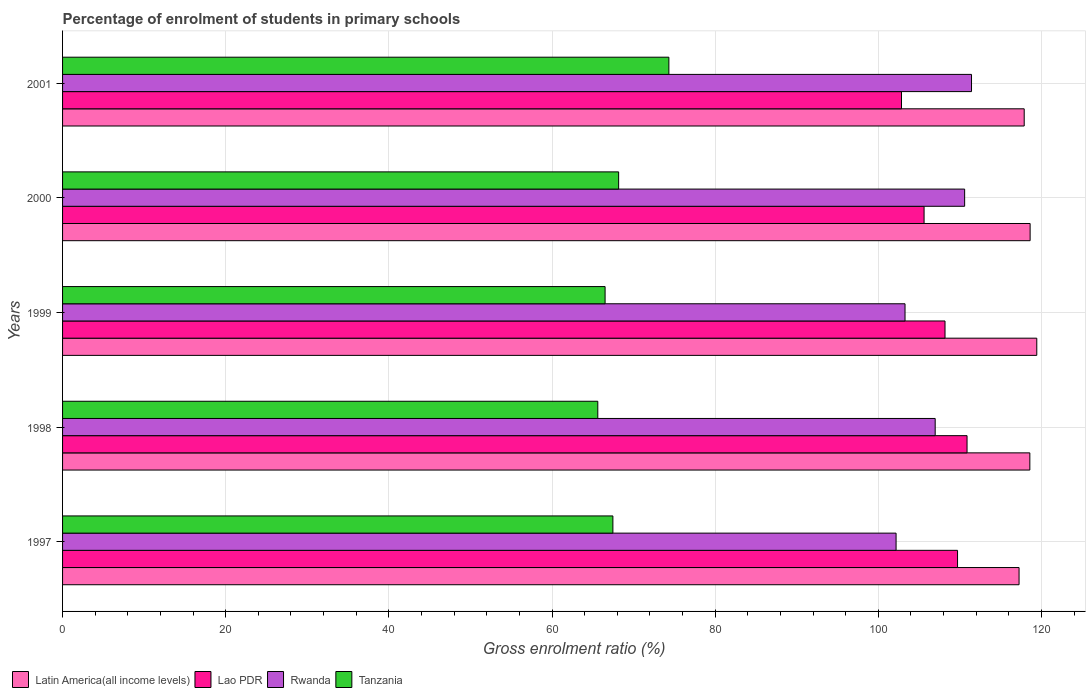Are the number of bars on each tick of the Y-axis equal?
Make the answer very short. Yes. What is the percentage of students enrolled in primary schools in Latin America(all income levels) in 1998?
Provide a short and direct response. 118.58. Across all years, what is the maximum percentage of students enrolled in primary schools in Lao PDR?
Offer a very short reply. 110.88. Across all years, what is the minimum percentage of students enrolled in primary schools in Lao PDR?
Your answer should be compact. 102.84. In which year was the percentage of students enrolled in primary schools in Lao PDR minimum?
Your answer should be very brief. 2001. What is the total percentage of students enrolled in primary schools in Latin America(all income levels) in the graph?
Offer a very short reply. 591.75. What is the difference between the percentage of students enrolled in primary schools in Rwanda in 1999 and that in 2001?
Your answer should be very brief. -8.15. What is the difference between the percentage of students enrolled in primary schools in Rwanda in 2000 and the percentage of students enrolled in primary schools in Tanzania in 1997?
Give a very brief answer. 43.12. What is the average percentage of students enrolled in primary schools in Lao PDR per year?
Ensure brevity in your answer.  107.44. In the year 2000, what is the difference between the percentage of students enrolled in primary schools in Rwanda and percentage of students enrolled in primary schools in Lao PDR?
Your response must be concise. 4.97. In how many years, is the percentage of students enrolled in primary schools in Rwanda greater than 88 %?
Your answer should be compact. 5. What is the ratio of the percentage of students enrolled in primary schools in Tanzania in 1998 to that in 2001?
Provide a succinct answer. 0.88. What is the difference between the highest and the second highest percentage of students enrolled in primary schools in Lao PDR?
Your answer should be very brief. 1.16. What is the difference between the highest and the lowest percentage of students enrolled in primary schools in Lao PDR?
Provide a succinct answer. 8.03. Is it the case that in every year, the sum of the percentage of students enrolled in primary schools in Lao PDR and percentage of students enrolled in primary schools in Tanzania is greater than the sum of percentage of students enrolled in primary schools in Latin America(all income levels) and percentage of students enrolled in primary schools in Rwanda?
Provide a short and direct response. No. What does the 2nd bar from the top in 1998 represents?
Ensure brevity in your answer.  Rwanda. What does the 3rd bar from the bottom in 1997 represents?
Make the answer very short. Rwanda. Is it the case that in every year, the sum of the percentage of students enrolled in primary schools in Latin America(all income levels) and percentage of students enrolled in primary schools in Lao PDR is greater than the percentage of students enrolled in primary schools in Tanzania?
Keep it short and to the point. Yes. Are all the bars in the graph horizontal?
Your response must be concise. Yes. Where does the legend appear in the graph?
Offer a terse response. Bottom left. How many legend labels are there?
Offer a terse response. 4. What is the title of the graph?
Give a very brief answer. Percentage of enrolment of students in primary schools. Does "Faeroe Islands" appear as one of the legend labels in the graph?
Offer a terse response. No. What is the label or title of the X-axis?
Your response must be concise. Gross enrolment ratio (%). What is the Gross enrolment ratio (%) of Latin America(all income levels) in 1997?
Keep it short and to the point. 117.25. What is the Gross enrolment ratio (%) in Lao PDR in 1997?
Offer a terse response. 109.71. What is the Gross enrolment ratio (%) in Rwanda in 1997?
Your answer should be compact. 102.18. What is the Gross enrolment ratio (%) of Tanzania in 1997?
Keep it short and to the point. 67.46. What is the Gross enrolment ratio (%) in Latin America(all income levels) in 1998?
Offer a terse response. 118.58. What is the Gross enrolment ratio (%) of Lao PDR in 1998?
Your answer should be compact. 110.88. What is the Gross enrolment ratio (%) in Rwanda in 1998?
Keep it short and to the point. 106.97. What is the Gross enrolment ratio (%) of Tanzania in 1998?
Your answer should be very brief. 65.61. What is the Gross enrolment ratio (%) in Latin America(all income levels) in 1999?
Offer a terse response. 119.43. What is the Gross enrolment ratio (%) in Lao PDR in 1999?
Provide a short and direct response. 108.18. What is the Gross enrolment ratio (%) in Rwanda in 1999?
Your response must be concise. 103.27. What is the Gross enrolment ratio (%) in Tanzania in 1999?
Give a very brief answer. 66.51. What is the Gross enrolment ratio (%) of Latin America(all income levels) in 2000?
Make the answer very short. 118.61. What is the Gross enrolment ratio (%) of Lao PDR in 2000?
Make the answer very short. 105.61. What is the Gross enrolment ratio (%) of Rwanda in 2000?
Offer a very short reply. 110.58. What is the Gross enrolment ratio (%) in Tanzania in 2000?
Give a very brief answer. 68.17. What is the Gross enrolment ratio (%) in Latin America(all income levels) in 2001?
Ensure brevity in your answer.  117.88. What is the Gross enrolment ratio (%) of Lao PDR in 2001?
Give a very brief answer. 102.84. What is the Gross enrolment ratio (%) in Rwanda in 2001?
Offer a very short reply. 111.42. What is the Gross enrolment ratio (%) in Tanzania in 2001?
Give a very brief answer. 74.33. Across all years, what is the maximum Gross enrolment ratio (%) in Latin America(all income levels)?
Your response must be concise. 119.43. Across all years, what is the maximum Gross enrolment ratio (%) in Lao PDR?
Make the answer very short. 110.88. Across all years, what is the maximum Gross enrolment ratio (%) of Rwanda?
Offer a very short reply. 111.42. Across all years, what is the maximum Gross enrolment ratio (%) of Tanzania?
Your response must be concise. 74.33. Across all years, what is the minimum Gross enrolment ratio (%) of Latin America(all income levels)?
Keep it short and to the point. 117.25. Across all years, what is the minimum Gross enrolment ratio (%) in Lao PDR?
Your answer should be compact. 102.84. Across all years, what is the minimum Gross enrolment ratio (%) of Rwanda?
Offer a very short reply. 102.18. Across all years, what is the minimum Gross enrolment ratio (%) of Tanzania?
Provide a succinct answer. 65.61. What is the total Gross enrolment ratio (%) in Latin America(all income levels) in the graph?
Offer a very short reply. 591.75. What is the total Gross enrolment ratio (%) of Lao PDR in the graph?
Offer a terse response. 537.22. What is the total Gross enrolment ratio (%) of Rwanda in the graph?
Give a very brief answer. 534.43. What is the total Gross enrolment ratio (%) in Tanzania in the graph?
Your response must be concise. 342.07. What is the difference between the Gross enrolment ratio (%) of Latin America(all income levels) in 1997 and that in 1998?
Ensure brevity in your answer.  -1.32. What is the difference between the Gross enrolment ratio (%) of Lao PDR in 1997 and that in 1998?
Make the answer very short. -1.16. What is the difference between the Gross enrolment ratio (%) of Rwanda in 1997 and that in 1998?
Provide a succinct answer. -4.79. What is the difference between the Gross enrolment ratio (%) in Tanzania in 1997 and that in 1998?
Offer a very short reply. 1.85. What is the difference between the Gross enrolment ratio (%) in Latin America(all income levels) in 1997 and that in 1999?
Your answer should be compact. -2.17. What is the difference between the Gross enrolment ratio (%) of Lao PDR in 1997 and that in 1999?
Provide a succinct answer. 1.54. What is the difference between the Gross enrolment ratio (%) of Rwanda in 1997 and that in 1999?
Offer a terse response. -1.1. What is the difference between the Gross enrolment ratio (%) in Tanzania in 1997 and that in 1999?
Make the answer very short. 0.95. What is the difference between the Gross enrolment ratio (%) of Latin America(all income levels) in 1997 and that in 2000?
Keep it short and to the point. -1.36. What is the difference between the Gross enrolment ratio (%) in Lao PDR in 1997 and that in 2000?
Your answer should be very brief. 4.1. What is the difference between the Gross enrolment ratio (%) of Rwanda in 1997 and that in 2000?
Your response must be concise. -8.4. What is the difference between the Gross enrolment ratio (%) of Tanzania in 1997 and that in 2000?
Make the answer very short. -0.71. What is the difference between the Gross enrolment ratio (%) of Latin America(all income levels) in 1997 and that in 2001?
Ensure brevity in your answer.  -0.63. What is the difference between the Gross enrolment ratio (%) of Lao PDR in 1997 and that in 2001?
Offer a terse response. 6.87. What is the difference between the Gross enrolment ratio (%) in Rwanda in 1997 and that in 2001?
Offer a terse response. -9.25. What is the difference between the Gross enrolment ratio (%) in Tanzania in 1997 and that in 2001?
Provide a short and direct response. -6.86. What is the difference between the Gross enrolment ratio (%) in Latin America(all income levels) in 1998 and that in 1999?
Offer a very short reply. -0.85. What is the difference between the Gross enrolment ratio (%) of Lao PDR in 1998 and that in 1999?
Give a very brief answer. 2.7. What is the difference between the Gross enrolment ratio (%) in Rwanda in 1998 and that in 1999?
Provide a succinct answer. 3.7. What is the difference between the Gross enrolment ratio (%) in Tanzania in 1998 and that in 1999?
Make the answer very short. -0.9. What is the difference between the Gross enrolment ratio (%) in Latin America(all income levels) in 1998 and that in 2000?
Your answer should be compact. -0.03. What is the difference between the Gross enrolment ratio (%) of Lao PDR in 1998 and that in 2000?
Make the answer very short. 5.27. What is the difference between the Gross enrolment ratio (%) of Rwanda in 1998 and that in 2000?
Your response must be concise. -3.61. What is the difference between the Gross enrolment ratio (%) in Tanzania in 1998 and that in 2000?
Give a very brief answer. -2.56. What is the difference between the Gross enrolment ratio (%) of Latin America(all income levels) in 1998 and that in 2001?
Keep it short and to the point. 0.69. What is the difference between the Gross enrolment ratio (%) of Lao PDR in 1998 and that in 2001?
Give a very brief answer. 8.03. What is the difference between the Gross enrolment ratio (%) of Rwanda in 1998 and that in 2001?
Your answer should be very brief. -4.45. What is the difference between the Gross enrolment ratio (%) in Tanzania in 1998 and that in 2001?
Your answer should be compact. -8.71. What is the difference between the Gross enrolment ratio (%) in Latin America(all income levels) in 1999 and that in 2000?
Make the answer very short. 0.82. What is the difference between the Gross enrolment ratio (%) in Lao PDR in 1999 and that in 2000?
Ensure brevity in your answer.  2.57. What is the difference between the Gross enrolment ratio (%) in Rwanda in 1999 and that in 2000?
Provide a short and direct response. -7.31. What is the difference between the Gross enrolment ratio (%) of Tanzania in 1999 and that in 2000?
Provide a short and direct response. -1.66. What is the difference between the Gross enrolment ratio (%) in Latin America(all income levels) in 1999 and that in 2001?
Provide a short and direct response. 1.54. What is the difference between the Gross enrolment ratio (%) in Lao PDR in 1999 and that in 2001?
Give a very brief answer. 5.33. What is the difference between the Gross enrolment ratio (%) of Rwanda in 1999 and that in 2001?
Provide a short and direct response. -8.15. What is the difference between the Gross enrolment ratio (%) in Tanzania in 1999 and that in 2001?
Make the answer very short. -7.82. What is the difference between the Gross enrolment ratio (%) in Latin America(all income levels) in 2000 and that in 2001?
Provide a short and direct response. 0.73. What is the difference between the Gross enrolment ratio (%) of Lao PDR in 2000 and that in 2001?
Give a very brief answer. 2.77. What is the difference between the Gross enrolment ratio (%) in Rwanda in 2000 and that in 2001?
Your response must be concise. -0.84. What is the difference between the Gross enrolment ratio (%) in Tanzania in 2000 and that in 2001?
Offer a very short reply. -6.16. What is the difference between the Gross enrolment ratio (%) in Latin America(all income levels) in 1997 and the Gross enrolment ratio (%) in Lao PDR in 1998?
Keep it short and to the point. 6.38. What is the difference between the Gross enrolment ratio (%) of Latin America(all income levels) in 1997 and the Gross enrolment ratio (%) of Rwanda in 1998?
Offer a terse response. 10.28. What is the difference between the Gross enrolment ratio (%) in Latin America(all income levels) in 1997 and the Gross enrolment ratio (%) in Tanzania in 1998?
Give a very brief answer. 51.64. What is the difference between the Gross enrolment ratio (%) in Lao PDR in 1997 and the Gross enrolment ratio (%) in Rwanda in 1998?
Offer a terse response. 2.74. What is the difference between the Gross enrolment ratio (%) of Lao PDR in 1997 and the Gross enrolment ratio (%) of Tanzania in 1998?
Provide a succinct answer. 44.1. What is the difference between the Gross enrolment ratio (%) in Rwanda in 1997 and the Gross enrolment ratio (%) in Tanzania in 1998?
Keep it short and to the point. 36.57. What is the difference between the Gross enrolment ratio (%) of Latin America(all income levels) in 1997 and the Gross enrolment ratio (%) of Lao PDR in 1999?
Keep it short and to the point. 9.08. What is the difference between the Gross enrolment ratio (%) of Latin America(all income levels) in 1997 and the Gross enrolment ratio (%) of Rwanda in 1999?
Offer a very short reply. 13.98. What is the difference between the Gross enrolment ratio (%) of Latin America(all income levels) in 1997 and the Gross enrolment ratio (%) of Tanzania in 1999?
Make the answer very short. 50.75. What is the difference between the Gross enrolment ratio (%) of Lao PDR in 1997 and the Gross enrolment ratio (%) of Rwanda in 1999?
Offer a terse response. 6.44. What is the difference between the Gross enrolment ratio (%) in Lao PDR in 1997 and the Gross enrolment ratio (%) in Tanzania in 1999?
Offer a terse response. 43.21. What is the difference between the Gross enrolment ratio (%) of Rwanda in 1997 and the Gross enrolment ratio (%) of Tanzania in 1999?
Ensure brevity in your answer.  35.67. What is the difference between the Gross enrolment ratio (%) of Latin America(all income levels) in 1997 and the Gross enrolment ratio (%) of Lao PDR in 2000?
Make the answer very short. 11.64. What is the difference between the Gross enrolment ratio (%) in Latin America(all income levels) in 1997 and the Gross enrolment ratio (%) in Rwanda in 2000?
Make the answer very short. 6.67. What is the difference between the Gross enrolment ratio (%) in Latin America(all income levels) in 1997 and the Gross enrolment ratio (%) in Tanzania in 2000?
Your response must be concise. 49.09. What is the difference between the Gross enrolment ratio (%) in Lao PDR in 1997 and the Gross enrolment ratio (%) in Rwanda in 2000?
Your answer should be compact. -0.87. What is the difference between the Gross enrolment ratio (%) of Lao PDR in 1997 and the Gross enrolment ratio (%) of Tanzania in 2000?
Ensure brevity in your answer.  41.55. What is the difference between the Gross enrolment ratio (%) in Rwanda in 1997 and the Gross enrolment ratio (%) in Tanzania in 2000?
Ensure brevity in your answer.  34.01. What is the difference between the Gross enrolment ratio (%) of Latin America(all income levels) in 1997 and the Gross enrolment ratio (%) of Lao PDR in 2001?
Provide a short and direct response. 14.41. What is the difference between the Gross enrolment ratio (%) in Latin America(all income levels) in 1997 and the Gross enrolment ratio (%) in Rwanda in 2001?
Your answer should be very brief. 5.83. What is the difference between the Gross enrolment ratio (%) of Latin America(all income levels) in 1997 and the Gross enrolment ratio (%) of Tanzania in 2001?
Keep it short and to the point. 42.93. What is the difference between the Gross enrolment ratio (%) of Lao PDR in 1997 and the Gross enrolment ratio (%) of Rwanda in 2001?
Provide a succinct answer. -1.71. What is the difference between the Gross enrolment ratio (%) in Lao PDR in 1997 and the Gross enrolment ratio (%) in Tanzania in 2001?
Keep it short and to the point. 35.39. What is the difference between the Gross enrolment ratio (%) in Rwanda in 1997 and the Gross enrolment ratio (%) in Tanzania in 2001?
Provide a succinct answer. 27.85. What is the difference between the Gross enrolment ratio (%) in Latin America(all income levels) in 1998 and the Gross enrolment ratio (%) in Lao PDR in 1999?
Your response must be concise. 10.4. What is the difference between the Gross enrolment ratio (%) of Latin America(all income levels) in 1998 and the Gross enrolment ratio (%) of Rwanda in 1999?
Provide a short and direct response. 15.3. What is the difference between the Gross enrolment ratio (%) of Latin America(all income levels) in 1998 and the Gross enrolment ratio (%) of Tanzania in 1999?
Your answer should be compact. 52.07. What is the difference between the Gross enrolment ratio (%) of Lao PDR in 1998 and the Gross enrolment ratio (%) of Rwanda in 1999?
Your answer should be compact. 7.6. What is the difference between the Gross enrolment ratio (%) in Lao PDR in 1998 and the Gross enrolment ratio (%) in Tanzania in 1999?
Provide a succinct answer. 44.37. What is the difference between the Gross enrolment ratio (%) of Rwanda in 1998 and the Gross enrolment ratio (%) of Tanzania in 1999?
Provide a succinct answer. 40.46. What is the difference between the Gross enrolment ratio (%) in Latin America(all income levels) in 1998 and the Gross enrolment ratio (%) in Lao PDR in 2000?
Keep it short and to the point. 12.97. What is the difference between the Gross enrolment ratio (%) of Latin America(all income levels) in 1998 and the Gross enrolment ratio (%) of Rwanda in 2000?
Offer a very short reply. 7.99. What is the difference between the Gross enrolment ratio (%) in Latin America(all income levels) in 1998 and the Gross enrolment ratio (%) in Tanzania in 2000?
Give a very brief answer. 50.41. What is the difference between the Gross enrolment ratio (%) of Lao PDR in 1998 and the Gross enrolment ratio (%) of Rwanda in 2000?
Make the answer very short. 0.29. What is the difference between the Gross enrolment ratio (%) in Lao PDR in 1998 and the Gross enrolment ratio (%) in Tanzania in 2000?
Give a very brief answer. 42.71. What is the difference between the Gross enrolment ratio (%) in Rwanda in 1998 and the Gross enrolment ratio (%) in Tanzania in 2000?
Keep it short and to the point. 38.8. What is the difference between the Gross enrolment ratio (%) of Latin America(all income levels) in 1998 and the Gross enrolment ratio (%) of Lao PDR in 2001?
Ensure brevity in your answer.  15.73. What is the difference between the Gross enrolment ratio (%) in Latin America(all income levels) in 1998 and the Gross enrolment ratio (%) in Rwanda in 2001?
Provide a succinct answer. 7.15. What is the difference between the Gross enrolment ratio (%) of Latin America(all income levels) in 1998 and the Gross enrolment ratio (%) of Tanzania in 2001?
Your answer should be very brief. 44.25. What is the difference between the Gross enrolment ratio (%) in Lao PDR in 1998 and the Gross enrolment ratio (%) in Rwanda in 2001?
Your answer should be compact. -0.55. What is the difference between the Gross enrolment ratio (%) of Lao PDR in 1998 and the Gross enrolment ratio (%) of Tanzania in 2001?
Keep it short and to the point. 36.55. What is the difference between the Gross enrolment ratio (%) in Rwanda in 1998 and the Gross enrolment ratio (%) in Tanzania in 2001?
Offer a very short reply. 32.65. What is the difference between the Gross enrolment ratio (%) of Latin America(all income levels) in 1999 and the Gross enrolment ratio (%) of Lao PDR in 2000?
Your response must be concise. 13.82. What is the difference between the Gross enrolment ratio (%) in Latin America(all income levels) in 1999 and the Gross enrolment ratio (%) in Rwanda in 2000?
Give a very brief answer. 8.84. What is the difference between the Gross enrolment ratio (%) of Latin America(all income levels) in 1999 and the Gross enrolment ratio (%) of Tanzania in 2000?
Your response must be concise. 51.26. What is the difference between the Gross enrolment ratio (%) of Lao PDR in 1999 and the Gross enrolment ratio (%) of Rwanda in 2000?
Provide a succinct answer. -2.4. What is the difference between the Gross enrolment ratio (%) in Lao PDR in 1999 and the Gross enrolment ratio (%) in Tanzania in 2000?
Make the answer very short. 40.01. What is the difference between the Gross enrolment ratio (%) of Rwanda in 1999 and the Gross enrolment ratio (%) of Tanzania in 2000?
Give a very brief answer. 35.11. What is the difference between the Gross enrolment ratio (%) of Latin America(all income levels) in 1999 and the Gross enrolment ratio (%) of Lao PDR in 2001?
Provide a succinct answer. 16.58. What is the difference between the Gross enrolment ratio (%) in Latin America(all income levels) in 1999 and the Gross enrolment ratio (%) in Rwanda in 2001?
Keep it short and to the point. 8. What is the difference between the Gross enrolment ratio (%) in Latin America(all income levels) in 1999 and the Gross enrolment ratio (%) in Tanzania in 2001?
Your answer should be compact. 45.1. What is the difference between the Gross enrolment ratio (%) in Lao PDR in 1999 and the Gross enrolment ratio (%) in Rwanda in 2001?
Provide a succinct answer. -3.25. What is the difference between the Gross enrolment ratio (%) in Lao PDR in 1999 and the Gross enrolment ratio (%) in Tanzania in 2001?
Your response must be concise. 33.85. What is the difference between the Gross enrolment ratio (%) of Rwanda in 1999 and the Gross enrolment ratio (%) of Tanzania in 2001?
Provide a short and direct response. 28.95. What is the difference between the Gross enrolment ratio (%) of Latin America(all income levels) in 2000 and the Gross enrolment ratio (%) of Lao PDR in 2001?
Offer a very short reply. 15.77. What is the difference between the Gross enrolment ratio (%) in Latin America(all income levels) in 2000 and the Gross enrolment ratio (%) in Rwanda in 2001?
Offer a terse response. 7.19. What is the difference between the Gross enrolment ratio (%) of Latin America(all income levels) in 2000 and the Gross enrolment ratio (%) of Tanzania in 2001?
Ensure brevity in your answer.  44.28. What is the difference between the Gross enrolment ratio (%) in Lao PDR in 2000 and the Gross enrolment ratio (%) in Rwanda in 2001?
Your response must be concise. -5.81. What is the difference between the Gross enrolment ratio (%) in Lao PDR in 2000 and the Gross enrolment ratio (%) in Tanzania in 2001?
Provide a succinct answer. 31.28. What is the difference between the Gross enrolment ratio (%) in Rwanda in 2000 and the Gross enrolment ratio (%) in Tanzania in 2001?
Provide a succinct answer. 36.26. What is the average Gross enrolment ratio (%) of Latin America(all income levels) per year?
Provide a succinct answer. 118.35. What is the average Gross enrolment ratio (%) in Lao PDR per year?
Keep it short and to the point. 107.44. What is the average Gross enrolment ratio (%) in Rwanda per year?
Your response must be concise. 106.89. What is the average Gross enrolment ratio (%) in Tanzania per year?
Offer a terse response. 68.41. In the year 1997, what is the difference between the Gross enrolment ratio (%) in Latin America(all income levels) and Gross enrolment ratio (%) in Lao PDR?
Provide a succinct answer. 7.54. In the year 1997, what is the difference between the Gross enrolment ratio (%) of Latin America(all income levels) and Gross enrolment ratio (%) of Rwanda?
Your answer should be very brief. 15.08. In the year 1997, what is the difference between the Gross enrolment ratio (%) in Latin America(all income levels) and Gross enrolment ratio (%) in Tanzania?
Your answer should be very brief. 49.79. In the year 1997, what is the difference between the Gross enrolment ratio (%) of Lao PDR and Gross enrolment ratio (%) of Rwanda?
Your answer should be compact. 7.53. In the year 1997, what is the difference between the Gross enrolment ratio (%) of Lao PDR and Gross enrolment ratio (%) of Tanzania?
Your answer should be very brief. 42.25. In the year 1997, what is the difference between the Gross enrolment ratio (%) in Rwanda and Gross enrolment ratio (%) in Tanzania?
Offer a very short reply. 34.72. In the year 1998, what is the difference between the Gross enrolment ratio (%) in Latin America(all income levels) and Gross enrolment ratio (%) in Lao PDR?
Keep it short and to the point. 7.7. In the year 1998, what is the difference between the Gross enrolment ratio (%) of Latin America(all income levels) and Gross enrolment ratio (%) of Rwanda?
Give a very brief answer. 11.6. In the year 1998, what is the difference between the Gross enrolment ratio (%) in Latin America(all income levels) and Gross enrolment ratio (%) in Tanzania?
Provide a short and direct response. 52.96. In the year 1998, what is the difference between the Gross enrolment ratio (%) in Lao PDR and Gross enrolment ratio (%) in Rwanda?
Offer a very short reply. 3.91. In the year 1998, what is the difference between the Gross enrolment ratio (%) of Lao PDR and Gross enrolment ratio (%) of Tanzania?
Offer a terse response. 45.27. In the year 1998, what is the difference between the Gross enrolment ratio (%) of Rwanda and Gross enrolment ratio (%) of Tanzania?
Make the answer very short. 41.36. In the year 1999, what is the difference between the Gross enrolment ratio (%) in Latin America(all income levels) and Gross enrolment ratio (%) in Lao PDR?
Your response must be concise. 11.25. In the year 1999, what is the difference between the Gross enrolment ratio (%) of Latin America(all income levels) and Gross enrolment ratio (%) of Rwanda?
Offer a very short reply. 16.15. In the year 1999, what is the difference between the Gross enrolment ratio (%) of Latin America(all income levels) and Gross enrolment ratio (%) of Tanzania?
Offer a very short reply. 52.92. In the year 1999, what is the difference between the Gross enrolment ratio (%) of Lao PDR and Gross enrolment ratio (%) of Rwanda?
Offer a terse response. 4.9. In the year 1999, what is the difference between the Gross enrolment ratio (%) in Lao PDR and Gross enrolment ratio (%) in Tanzania?
Make the answer very short. 41.67. In the year 1999, what is the difference between the Gross enrolment ratio (%) of Rwanda and Gross enrolment ratio (%) of Tanzania?
Ensure brevity in your answer.  36.77. In the year 2000, what is the difference between the Gross enrolment ratio (%) of Latin America(all income levels) and Gross enrolment ratio (%) of Lao PDR?
Offer a very short reply. 13. In the year 2000, what is the difference between the Gross enrolment ratio (%) in Latin America(all income levels) and Gross enrolment ratio (%) in Rwanda?
Make the answer very short. 8.03. In the year 2000, what is the difference between the Gross enrolment ratio (%) in Latin America(all income levels) and Gross enrolment ratio (%) in Tanzania?
Your answer should be compact. 50.44. In the year 2000, what is the difference between the Gross enrolment ratio (%) in Lao PDR and Gross enrolment ratio (%) in Rwanda?
Ensure brevity in your answer.  -4.97. In the year 2000, what is the difference between the Gross enrolment ratio (%) in Lao PDR and Gross enrolment ratio (%) in Tanzania?
Provide a succinct answer. 37.44. In the year 2000, what is the difference between the Gross enrolment ratio (%) of Rwanda and Gross enrolment ratio (%) of Tanzania?
Offer a terse response. 42.41. In the year 2001, what is the difference between the Gross enrolment ratio (%) in Latin America(all income levels) and Gross enrolment ratio (%) in Lao PDR?
Keep it short and to the point. 15.04. In the year 2001, what is the difference between the Gross enrolment ratio (%) in Latin America(all income levels) and Gross enrolment ratio (%) in Rwanda?
Ensure brevity in your answer.  6.46. In the year 2001, what is the difference between the Gross enrolment ratio (%) in Latin America(all income levels) and Gross enrolment ratio (%) in Tanzania?
Provide a succinct answer. 43.56. In the year 2001, what is the difference between the Gross enrolment ratio (%) of Lao PDR and Gross enrolment ratio (%) of Rwanda?
Provide a short and direct response. -8.58. In the year 2001, what is the difference between the Gross enrolment ratio (%) of Lao PDR and Gross enrolment ratio (%) of Tanzania?
Your answer should be very brief. 28.52. In the year 2001, what is the difference between the Gross enrolment ratio (%) in Rwanda and Gross enrolment ratio (%) in Tanzania?
Your answer should be very brief. 37.1. What is the ratio of the Gross enrolment ratio (%) in Latin America(all income levels) in 1997 to that in 1998?
Provide a short and direct response. 0.99. What is the ratio of the Gross enrolment ratio (%) in Lao PDR in 1997 to that in 1998?
Offer a terse response. 0.99. What is the ratio of the Gross enrolment ratio (%) of Rwanda in 1997 to that in 1998?
Make the answer very short. 0.96. What is the ratio of the Gross enrolment ratio (%) in Tanzania in 1997 to that in 1998?
Give a very brief answer. 1.03. What is the ratio of the Gross enrolment ratio (%) of Latin America(all income levels) in 1997 to that in 1999?
Your response must be concise. 0.98. What is the ratio of the Gross enrolment ratio (%) of Lao PDR in 1997 to that in 1999?
Make the answer very short. 1.01. What is the ratio of the Gross enrolment ratio (%) of Rwanda in 1997 to that in 1999?
Keep it short and to the point. 0.99. What is the ratio of the Gross enrolment ratio (%) of Tanzania in 1997 to that in 1999?
Provide a succinct answer. 1.01. What is the ratio of the Gross enrolment ratio (%) in Latin America(all income levels) in 1997 to that in 2000?
Provide a short and direct response. 0.99. What is the ratio of the Gross enrolment ratio (%) of Lao PDR in 1997 to that in 2000?
Make the answer very short. 1.04. What is the ratio of the Gross enrolment ratio (%) of Rwanda in 1997 to that in 2000?
Offer a terse response. 0.92. What is the ratio of the Gross enrolment ratio (%) of Lao PDR in 1997 to that in 2001?
Offer a very short reply. 1.07. What is the ratio of the Gross enrolment ratio (%) of Rwanda in 1997 to that in 2001?
Offer a terse response. 0.92. What is the ratio of the Gross enrolment ratio (%) in Tanzania in 1997 to that in 2001?
Provide a short and direct response. 0.91. What is the ratio of the Gross enrolment ratio (%) of Lao PDR in 1998 to that in 1999?
Offer a very short reply. 1.02. What is the ratio of the Gross enrolment ratio (%) of Rwanda in 1998 to that in 1999?
Offer a very short reply. 1.04. What is the ratio of the Gross enrolment ratio (%) in Tanzania in 1998 to that in 1999?
Offer a terse response. 0.99. What is the ratio of the Gross enrolment ratio (%) of Latin America(all income levels) in 1998 to that in 2000?
Offer a terse response. 1. What is the ratio of the Gross enrolment ratio (%) in Lao PDR in 1998 to that in 2000?
Offer a very short reply. 1.05. What is the ratio of the Gross enrolment ratio (%) of Rwanda in 1998 to that in 2000?
Keep it short and to the point. 0.97. What is the ratio of the Gross enrolment ratio (%) of Tanzania in 1998 to that in 2000?
Make the answer very short. 0.96. What is the ratio of the Gross enrolment ratio (%) of Latin America(all income levels) in 1998 to that in 2001?
Make the answer very short. 1.01. What is the ratio of the Gross enrolment ratio (%) of Lao PDR in 1998 to that in 2001?
Your response must be concise. 1.08. What is the ratio of the Gross enrolment ratio (%) in Tanzania in 1998 to that in 2001?
Make the answer very short. 0.88. What is the ratio of the Gross enrolment ratio (%) in Lao PDR in 1999 to that in 2000?
Provide a succinct answer. 1.02. What is the ratio of the Gross enrolment ratio (%) in Rwanda in 1999 to that in 2000?
Provide a short and direct response. 0.93. What is the ratio of the Gross enrolment ratio (%) of Tanzania in 1999 to that in 2000?
Offer a very short reply. 0.98. What is the ratio of the Gross enrolment ratio (%) in Latin America(all income levels) in 1999 to that in 2001?
Offer a terse response. 1.01. What is the ratio of the Gross enrolment ratio (%) in Lao PDR in 1999 to that in 2001?
Ensure brevity in your answer.  1.05. What is the ratio of the Gross enrolment ratio (%) in Rwanda in 1999 to that in 2001?
Give a very brief answer. 0.93. What is the ratio of the Gross enrolment ratio (%) of Tanzania in 1999 to that in 2001?
Keep it short and to the point. 0.89. What is the ratio of the Gross enrolment ratio (%) in Lao PDR in 2000 to that in 2001?
Offer a terse response. 1.03. What is the ratio of the Gross enrolment ratio (%) of Tanzania in 2000 to that in 2001?
Keep it short and to the point. 0.92. What is the difference between the highest and the second highest Gross enrolment ratio (%) in Latin America(all income levels)?
Your answer should be very brief. 0.82. What is the difference between the highest and the second highest Gross enrolment ratio (%) of Lao PDR?
Provide a short and direct response. 1.16. What is the difference between the highest and the second highest Gross enrolment ratio (%) of Rwanda?
Offer a very short reply. 0.84. What is the difference between the highest and the second highest Gross enrolment ratio (%) in Tanzania?
Provide a short and direct response. 6.16. What is the difference between the highest and the lowest Gross enrolment ratio (%) in Latin America(all income levels)?
Give a very brief answer. 2.17. What is the difference between the highest and the lowest Gross enrolment ratio (%) in Lao PDR?
Keep it short and to the point. 8.03. What is the difference between the highest and the lowest Gross enrolment ratio (%) in Rwanda?
Your answer should be compact. 9.25. What is the difference between the highest and the lowest Gross enrolment ratio (%) of Tanzania?
Offer a very short reply. 8.71. 